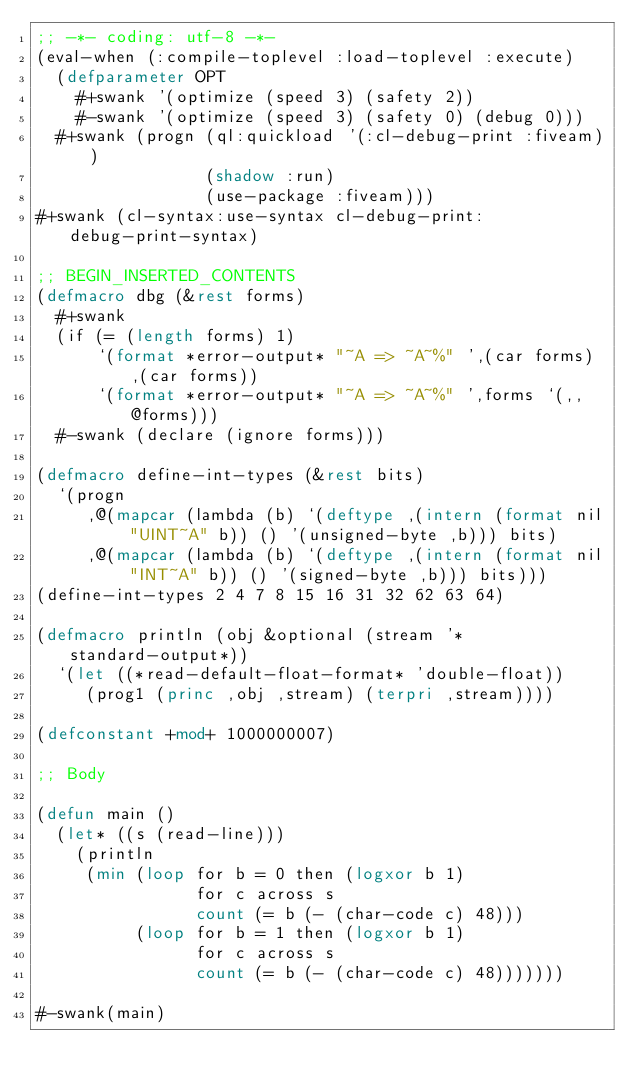<code> <loc_0><loc_0><loc_500><loc_500><_Lisp_>;; -*- coding: utf-8 -*-
(eval-when (:compile-toplevel :load-toplevel :execute)
  (defparameter OPT
    #+swank '(optimize (speed 3) (safety 2))
    #-swank '(optimize (speed 3) (safety 0) (debug 0)))
  #+swank (progn (ql:quickload '(:cl-debug-print :fiveam))
                 (shadow :run)
                 (use-package :fiveam)))
#+swank (cl-syntax:use-syntax cl-debug-print:debug-print-syntax)

;; BEGIN_INSERTED_CONTENTS
(defmacro dbg (&rest forms)
  #+swank
  (if (= (length forms) 1)
      `(format *error-output* "~A => ~A~%" ',(car forms) ,(car forms))
      `(format *error-output* "~A => ~A~%" ',forms `(,,@forms)))
  #-swank (declare (ignore forms)))

(defmacro define-int-types (&rest bits)
  `(progn
     ,@(mapcar (lambda (b) `(deftype ,(intern (format nil "UINT~A" b)) () '(unsigned-byte ,b))) bits)
     ,@(mapcar (lambda (b) `(deftype ,(intern (format nil "INT~A" b)) () '(signed-byte ,b))) bits)))
(define-int-types 2 4 7 8 15 16 31 32 62 63 64)

(defmacro println (obj &optional (stream '*standard-output*))
  `(let ((*read-default-float-format* 'double-float))
     (prog1 (princ ,obj ,stream) (terpri ,stream))))

(defconstant +mod+ 1000000007)

;; Body

(defun main ()
  (let* ((s (read-line)))
    (println
     (min (loop for b = 0 then (logxor b 1)
                for c across s
                count (= b (- (char-code c) 48)))
          (loop for b = 1 then (logxor b 1)
                for c across s
                count (= b (- (char-code c) 48)))))))

#-swank(main)
</code> 